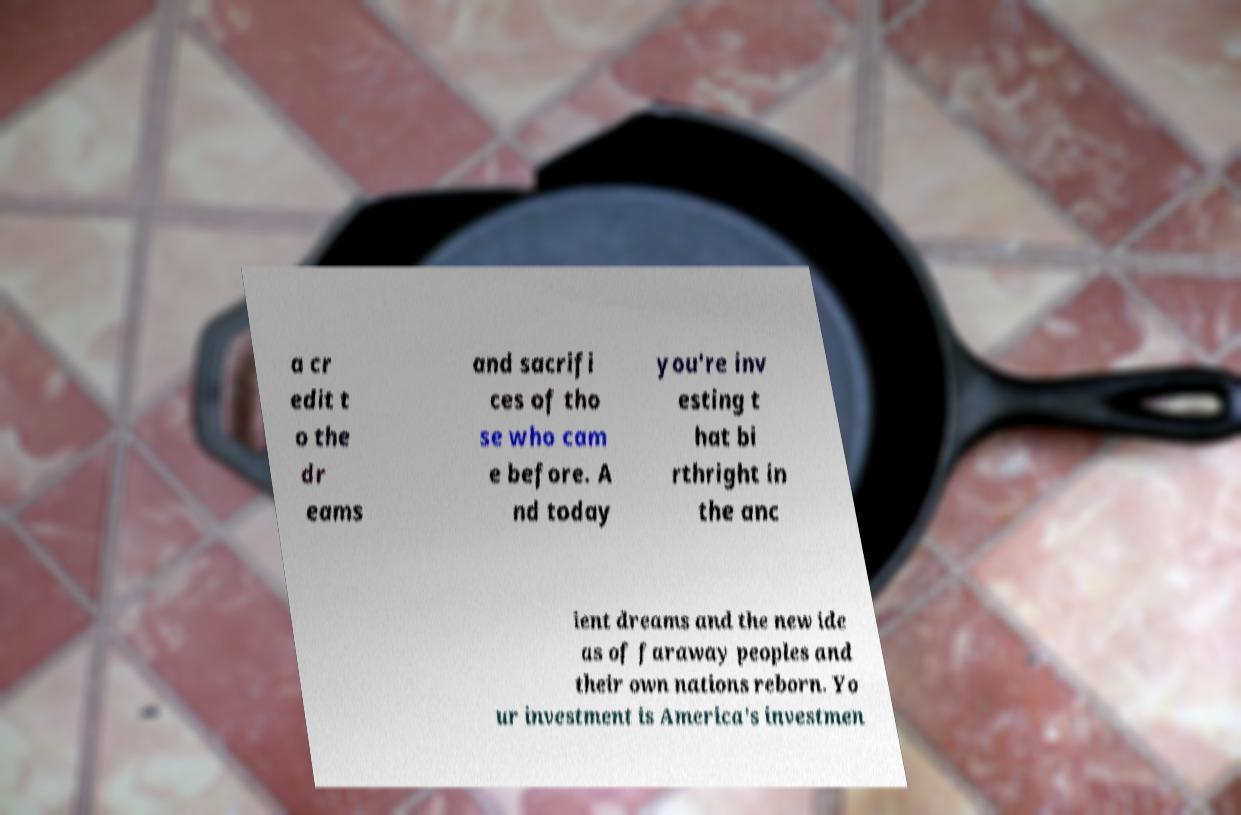Could you extract and type out the text from this image? a cr edit t o the dr eams and sacrifi ces of tho se who cam e before. A nd today you're inv esting t hat bi rthright in the anc ient dreams and the new ide as of faraway peoples and their own nations reborn. Yo ur investment is America's investmen 